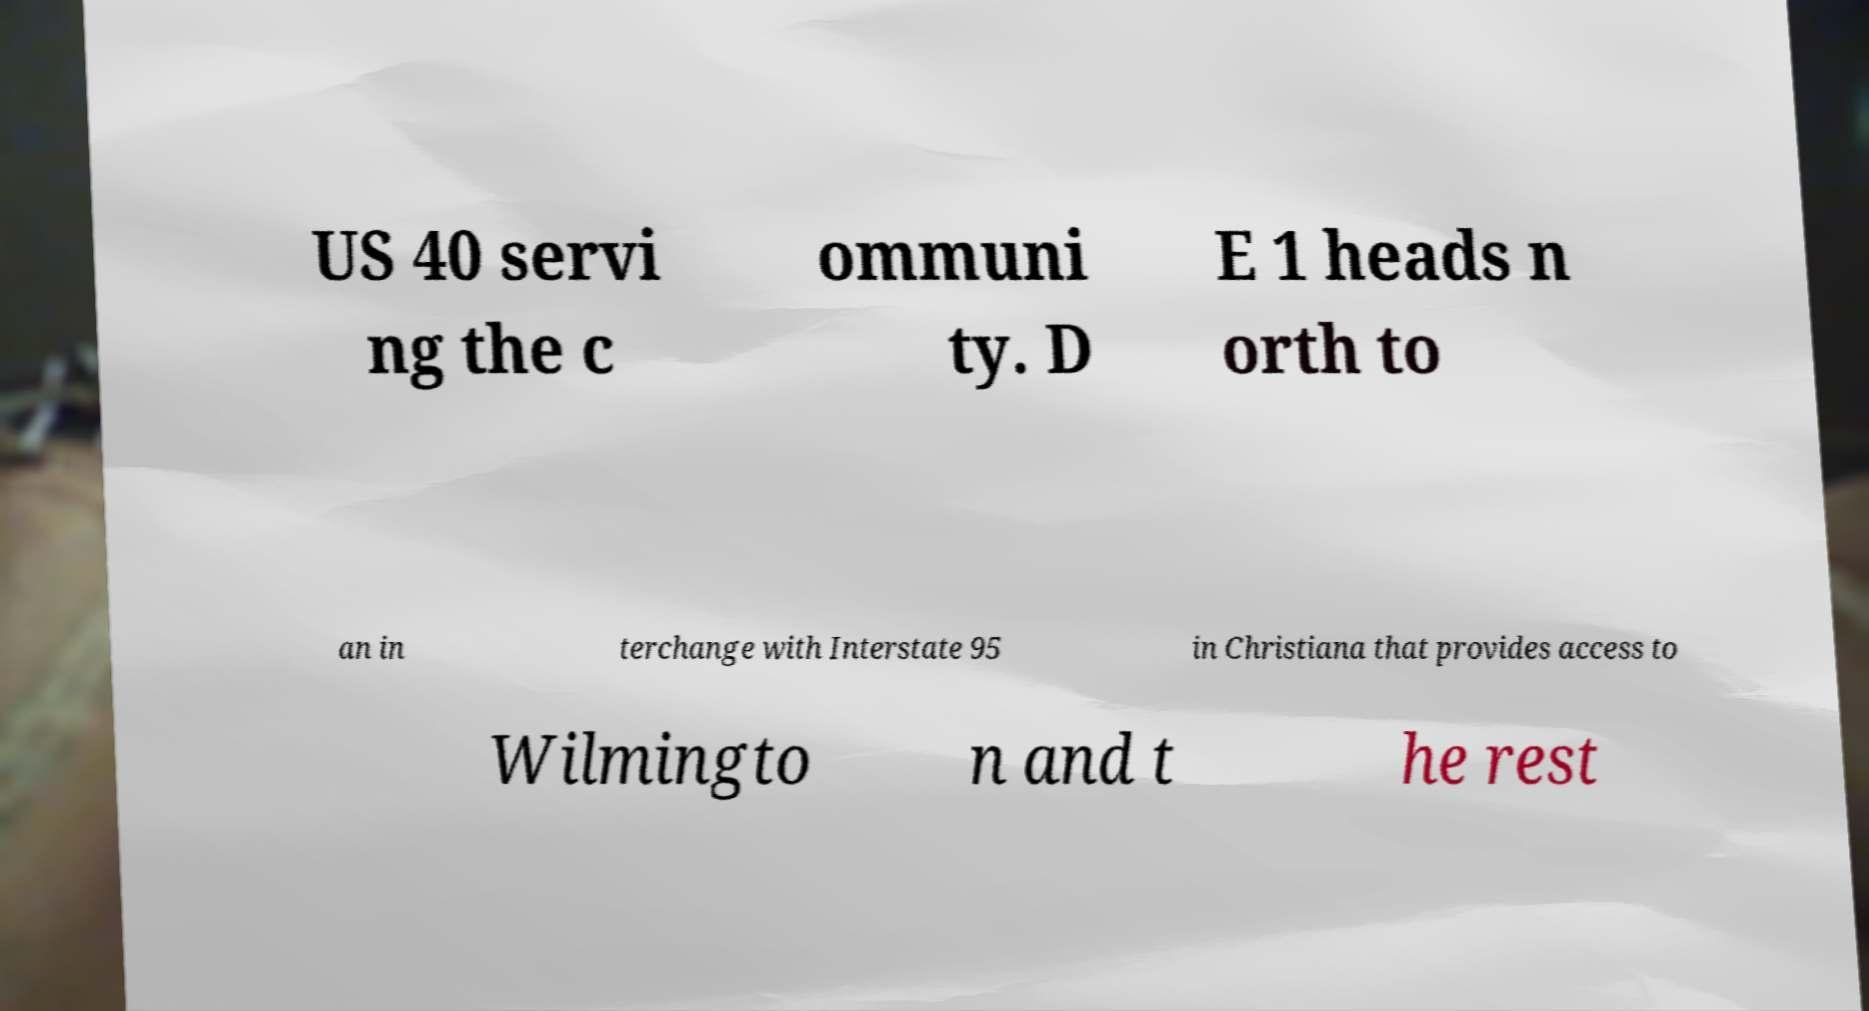There's text embedded in this image that I need extracted. Can you transcribe it verbatim? US 40 servi ng the c ommuni ty. D E 1 heads n orth to an in terchange with Interstate 95 in Christiana that provides access to Wilmingto n and t he rest 